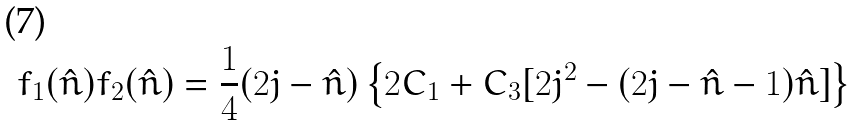Convert formula to latex. <formula><loc_0><loc_0><loc_500><loc_500>f _ { 1 } ( \hat { n } ) f _ { 2 } ( \hat { n } ) = \frac { 1 } { 4 } ( 2 j - \hat { n } ) \left \{ 2 C _ { 1 } + C _ { 3 } [ 2 j ^ { 2 } - ( 2 j - \hat { n } - 1 ) \hat { n } ] \right \}</formula> 